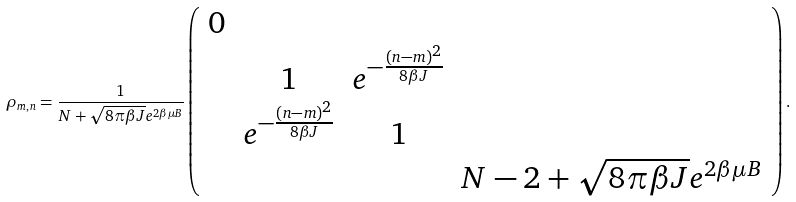<formula> <loc_0><loc_0><loc_500><loc_500>\rho _ { m , n } = \frac { 1 } { N + \sqrt { 8 \pi \beta J } e ^ { 2 \beta \mu B } } \left ( \begin{array} { c c c c } 0 & & & \\ & 1 & e ^ { - \frac { ( n - m ) ^ { 2 } } { 8 \beta J } } & \\ & e ^ { - \frac { ( n - m ) ^ { 2 } } { 8 \beta J } } & 1 & \\ & & & N - 2 + \sqrt { 8 \pi \beta J } e ^ { 2 \beta \mu B } \end{array} \right ) .</formula> 